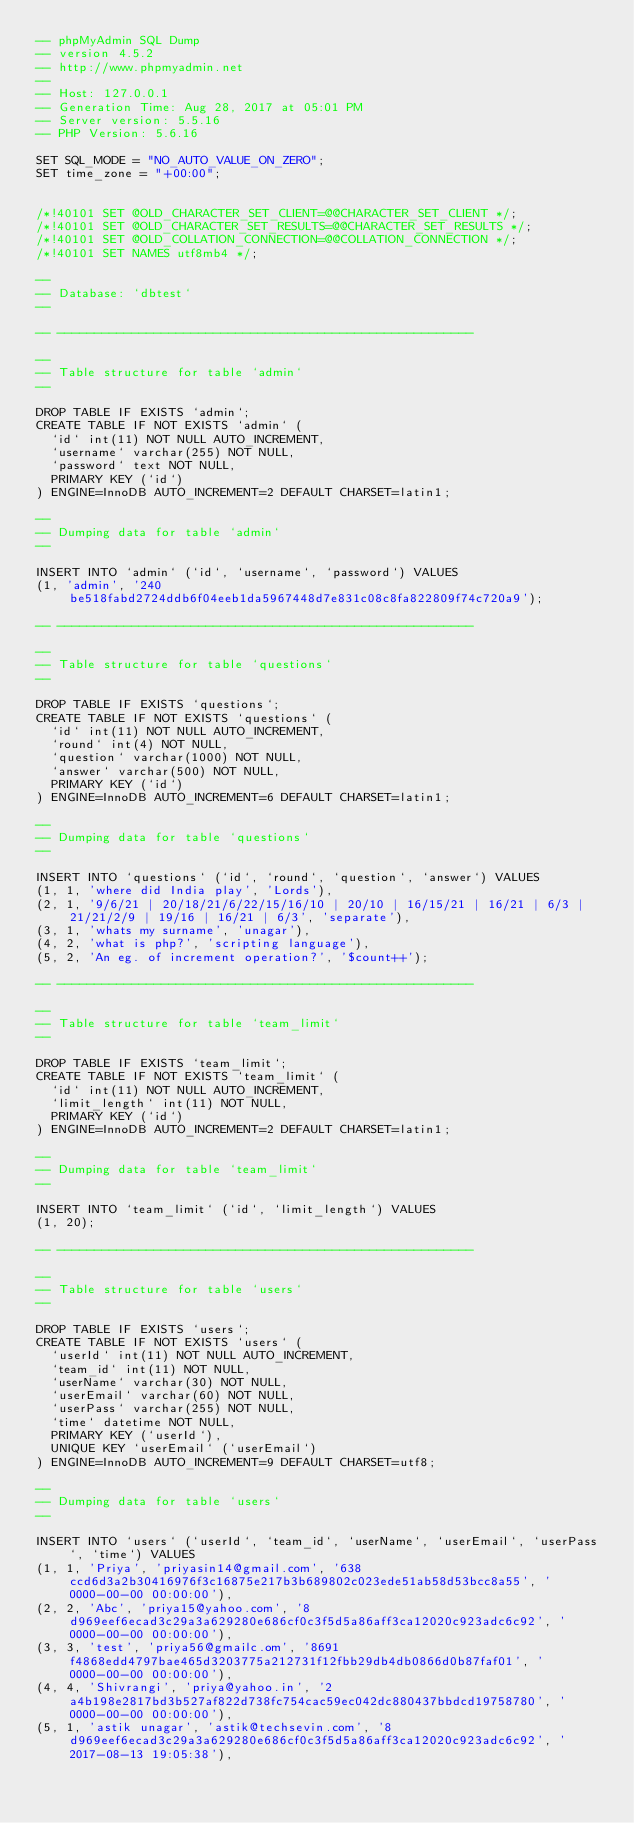Convert code to text. <code><loc_0><loc_0><loc_500><loc_500><_SQL_>-- phpMyAdmin SQL Dump
-- version 4.5.2
-- http://www.phpmyadmin.net
--
-- Host: 127.0.0.1
-- Generation Time: Aug 28, 2017 at 05:01 PM
-- Server version: 5.5.16
-- PHP Version: 5.6.16

SET SQL_MODE = "NO_AUTO_VALUE_ON_ZERO";
SET time_zone = "+00:00";


/*!40101 SET @OLD_CHARACTER_SET_CLIENT=@@CHARACTER_SET_CLIENT */;
/*!40101 SET @OLD_CHARACTER_SET_RESULTS=@@CHARACTER_SET_RESULTS */;
/*!40101 SET @OLD_COLLATION_CONNECTION=@@COLLATION_CONNECTION */;
/*!40101 SET NAMES utf8mb4 */;

--
-- Database: `dbtest`
--

-- --------------------------------------------------------

--
-- Table structure for table `admin`
--

DROP TABLE IF EXISTS `admin`;
CREATE TABLE IF NOT EXISTS `admin` (
  `id` int(11) NOT NULL AUTO_INCREMENT,
  `username` varchar(255) NOT NULL,
  `password` text NOT NULL,
  PRIMARY KEY (`id`)
) ENGINE=InnoDB AUTO_INCREMENT=2 DEFAULT CHARSET=latin1;

--
-- Dumping data for table `admin`
--

INSERT INTO `admin` (`id`, `username`, `password`) VALUES
(1, 'admin', '240be518fabd2724ddb6f04eeb1da5967448d7e831c08c8fa822809f74c720a9');

-- --------------------------------------------------------

--
-- Table structure for table `questions`
--

DROP TABLE IF EXISTS `questions`;
CREATE TABLE IF NOT EXISTS `questions` (
  `id` int(11) NOT NULL AUTO_INCREMENT,
  `round` int(4) NOT NULL,
  `question` varchar(1000) NOT NULL,
  `answer` varchar(500) NOT NULL,
  PRIMARY KEY (`id`)
) ENGINE=InnoDB AUTO_INCREMENT=6 DEFAULT CHARSET=latin1;

--
-- Dumping data for table `questions`
--

INSERT INTO `questions` (`id`, `round`, `question`, `answer`) VALUES
(1, 1, 'where did India play', 'Lords'),
(2, 1, '9/6/21 | 20/18/21/6/22/15/16/10 | 20/10 | 16/15/21 | 16/21 | 6/3 | 21/21/2/9 | 19/16 | 16/21 | 6/3', 'separate'),
(3, 1, 'whats my surname', 'unagar'),
(4, 2, 'what is php?', 'scripting language'),
(5, 2, 'An eg. of increment operation?', '$count++');

-- --------------------------------------------------------

--
-- Table structure for table `team_limit`
--

DROP TABLE IF EXISTS `team_limit`;
CREATE TABLE IF NOT EXISTS `team_limit` (
  `id` int(11) NOT NULL AUTO_INCREMENT,
  `limit_length` int(11) NOT NULL,
  PRIMARY KEY (`id`)
) ENGINE=InnoDB AUTO_INCREMENT=2 DEFAULT CHARSET=latin1;

--
-- Dumping data for table `team_limit`
--

INSERT INTO `team_limit` (`id`, `limit_length`) VALUES
(1, 20);

-- --------------------------------------------------------

--
-- Table structure for table `users`
--

DROP TABLE IF EXISTS `users`;
CREATE TABLE IF NOT EXISTS `users` (
  `userId` int(11) NOT NULL AUTO_INCREMENT,
  `team_id` int(11) NOT NULL,
  `userName` varchar(30) NOT NULL,
  `userEmail` varchar(60) NOT NULL,
  `userPass` varchar(255) NOT NULL,
  `time` datetime NOT NULL,
  PRIMARY KEY (`userId`),
  UNIQUE KEY `userEmail` (`userEmail`)
) ENGINE=InnoDB AUTO_INCREMENT=9 DEFAULT CHARSET=utf8;

--
-- Dumping data for table `users`
--

INSERT INTO `users` (`userId`, `team_id`, `userName`, `userEmail`, `userPass`, `time`) VALUES
(1, 1, 'Priya', 'priyasin14@gmail.com', '638ccd6d3a2b30416976f3c16875e217b3b689802c023ede51ab58d53bcc8a55', '0000-00-00 00:00:00'),
(2, 2, 'Abc', 'priya15@yahoo.com', '8d969eef6ecad3c29a3a629280e686cf0c3f5d5a86aff3ca12020c923adc6c92', '0000-00-00 00:00:00'),
(3, 3, 'test', 'priya56@gmailc.om', '8691f4868edd4797bae465d3203775a212731f12fbb29db4db0866d0b87faf01', '0000-00-00 00:00:00'),
(4, 4, 'Shivrangi', 'priya@yahoo.in', '2a4b198e2817bd3b527af822d738fc754cac59ec042dc880437bbdcd19758780', '0000-00-00 00:00:00'),
(5, 1, 'astik unagar', 'astik@techsevin.com', '8d969eef6ecad3c29a3a629280e686cf0c3f5d5a86aff3ca12020c923adc6c92', '2017-08-13 19:05:38'),</code> 